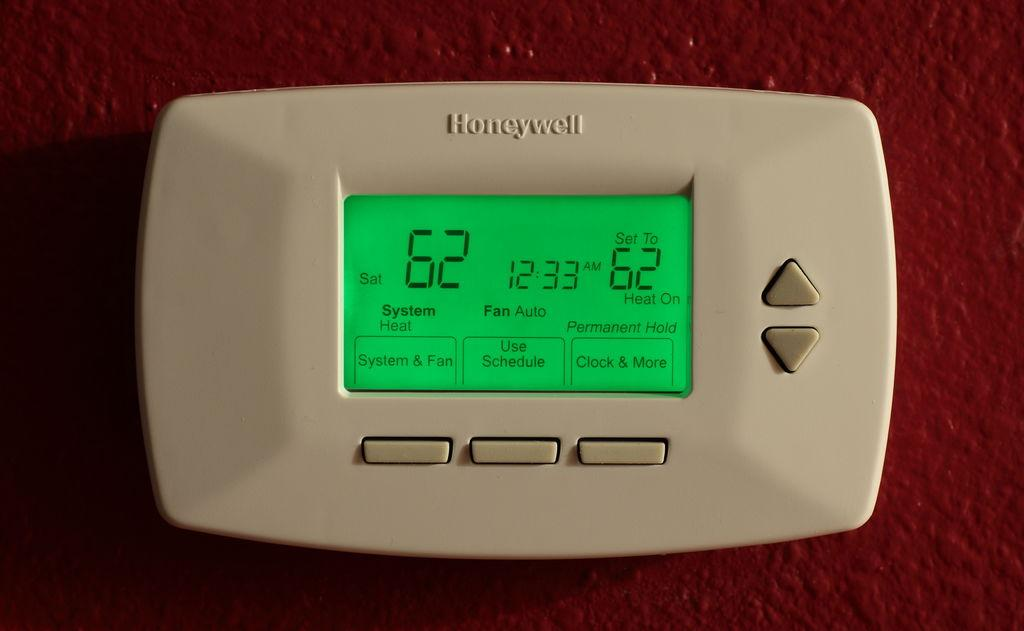<image>
Provide a brief description of the given image. A Honeywell thermostat displays the temperature and other information. 